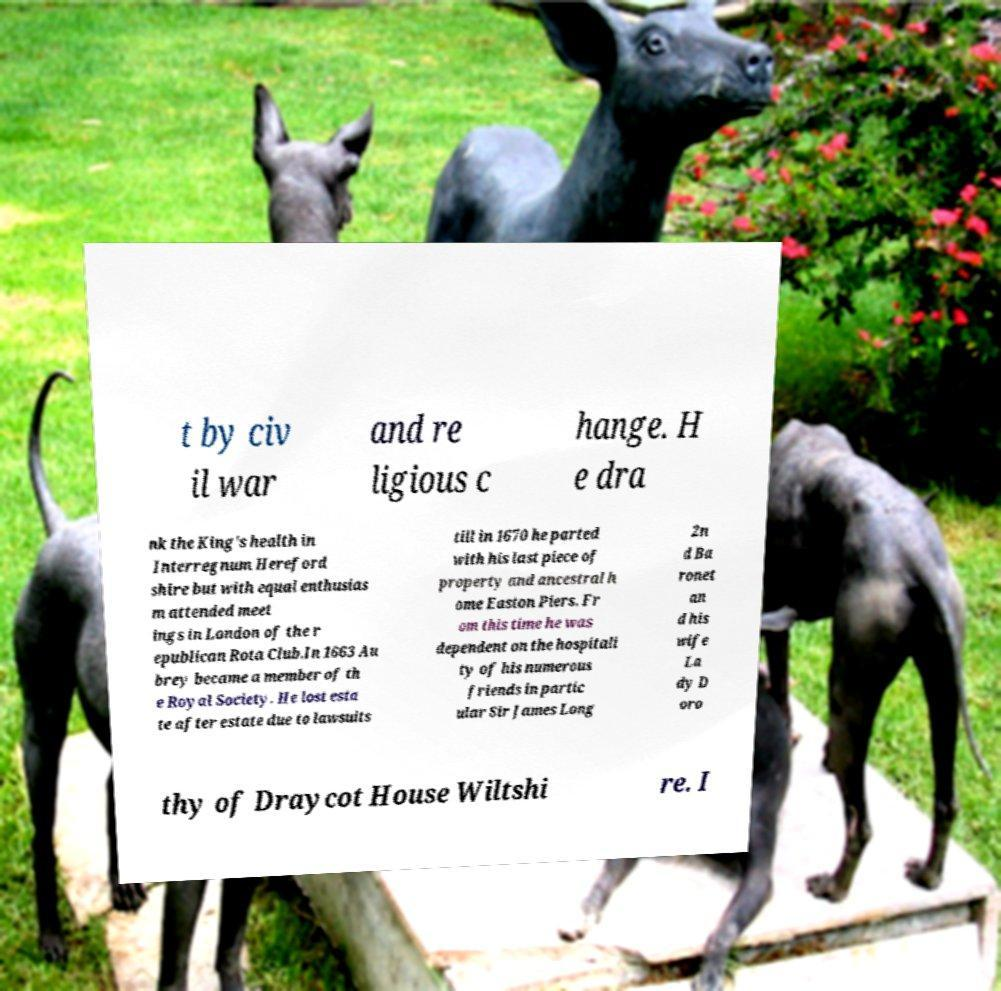For documentation purposes, I need the text within this image transcribed. Could you provide that? t by civ il war and re ligious c hange. H e dra nk the King's health in Interregnum Hereford shire but with equal enthusias m attended meet ings in London of the r epublican Rota Club.In 1663 Au brey became a member of th e Royal Society. He lost esta te after estate due to lawsuits till in 1670 he parted with his last piece of property and ancestral h ome Easton Piers. Fr om this time he was dependent on the hospitali ty of his numerous friends in partic ular Sir James Long 2n d Ba ronet an d his wife La dy D oro thy of Draycot House Wiltshi re. I 